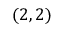<formula> <loc_0><loc_0><loc_500><loc_500>( 2 , 2 )</formula> 